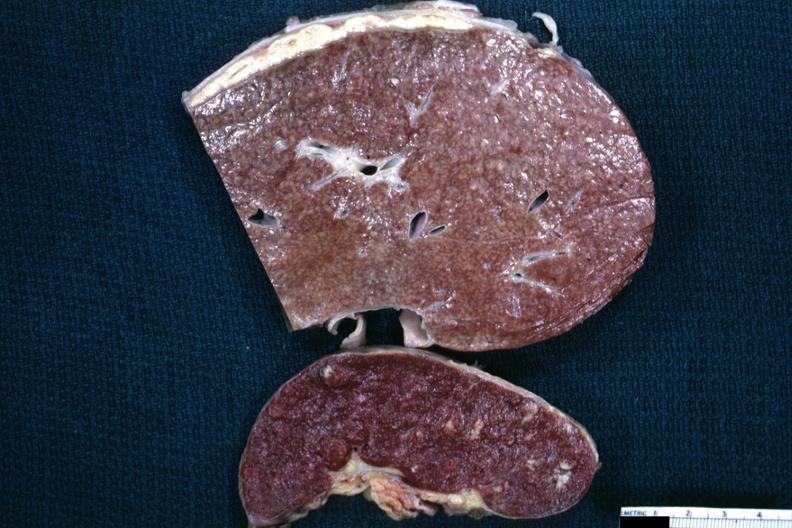what is a close-up view of the typical cold abscess exudate on the liver surface?
Answer the question using a single word or phrase. Granulomata slide 